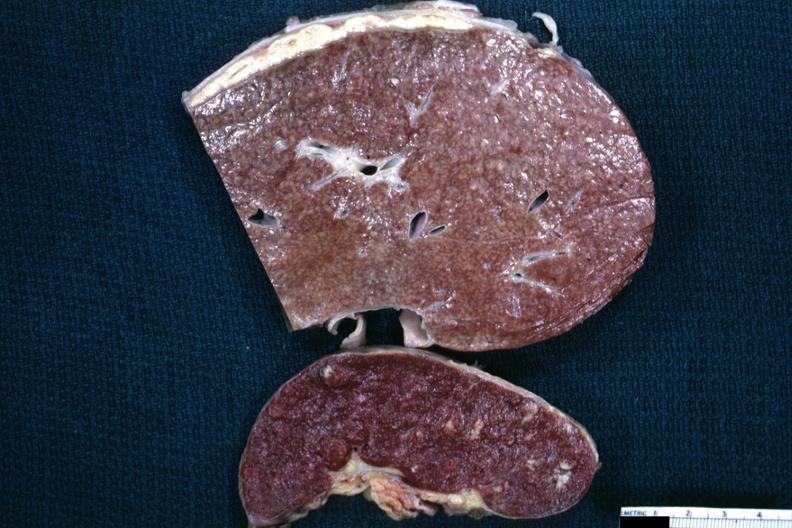what is a close-up view of the typical cold abscess exudate on the liver surface?
Answer the question using a single word or phrase. Granulomata slide 